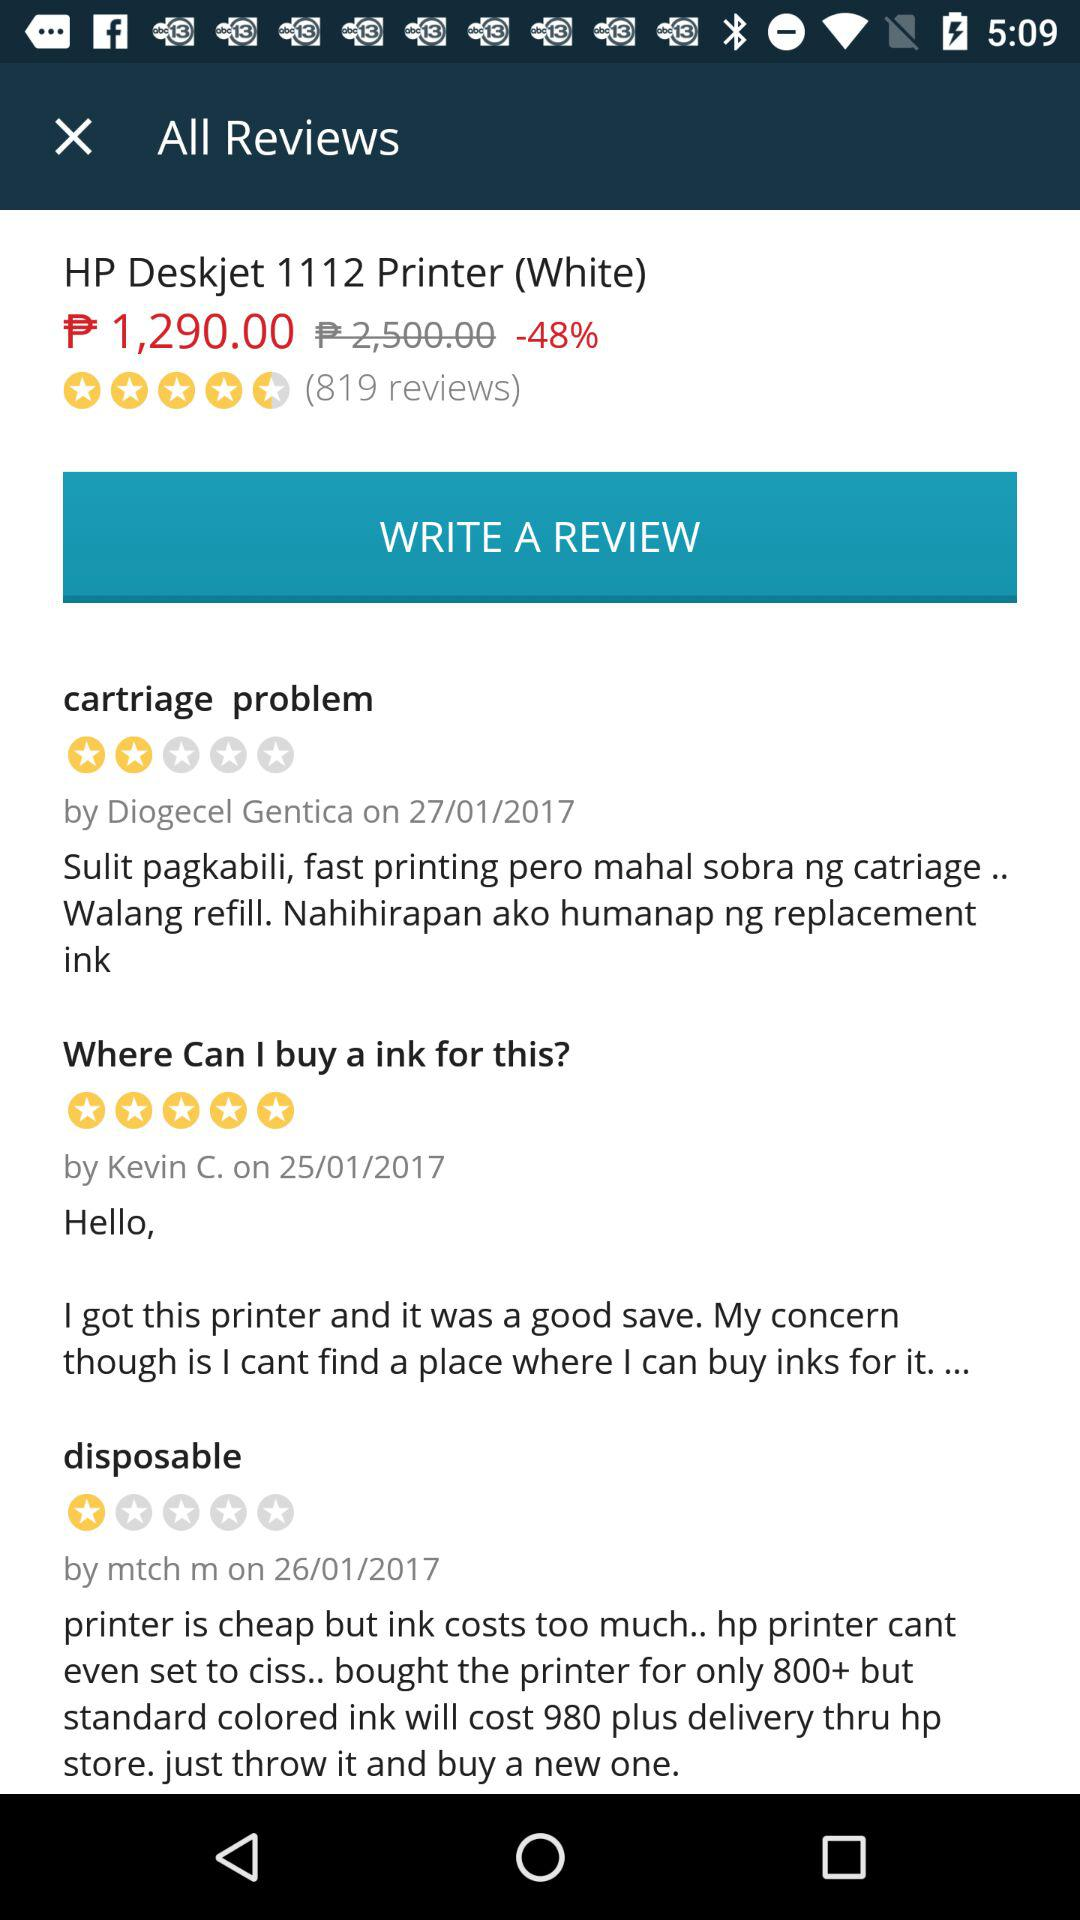How many stars are given for cartriage problem? The given stars are 2. 